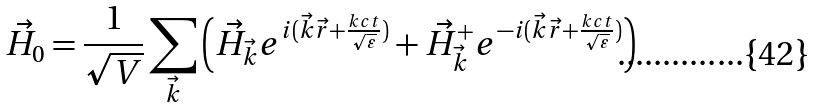Convert formula to latex. <formula><loc_0><loc_0><loc_500><loc_500>\vec { H } _ { 0 } = \frac { 1 } { \sqrt { V } } \sum _ { \vec { k } } \left ( \vec { H } _ { \vec { k } } e ^ { i ( \vec { k } \vec { r } + \frac { k c t } { \sqrt { \varepsilon } } ) } + \vec { H } ^ { + } _ { \vec { k } } e ^ { - i ( \vec { k } \vec { r } + \frac { k c t } { \sqrt { \varepsilon } } ) } \right )</formula> 